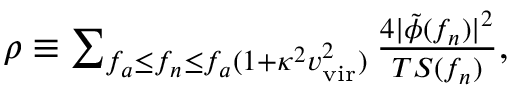Convert formula to latex. <formula><loc_0><loc_0><loc_500><loc_500>\begin{array} { r } { \rho \equiv \sum _ { f _ { a } \leq f _ { n } \leq f _ { a } ( 1 + \kappa ^ { 2 } v _ { v i r } ^ { 2 } ) } \frac { 4 | \tilde { \phi } ( f _ { n } ) | ^ { 2 } } { T S ( f _ { n } ) } , } \end{array}</formula> 